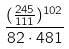Convert formula to latex. <formula><loc_0><loc_0><loc_500><loc_500>\frac { ( \frac { 2 4 5 } { 1 1 1 } ) ^ { 1 0 2 } } { 8 2 \cdot 4 8 1 }</formula> 